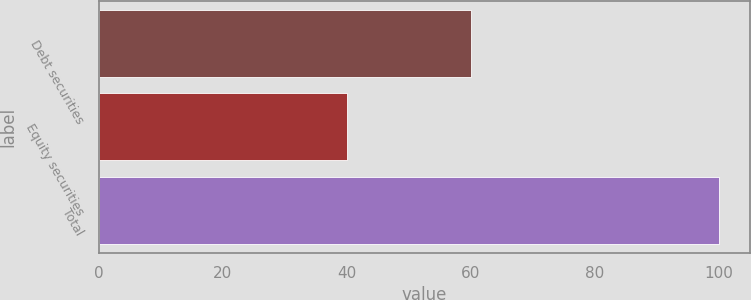Convert chart. <chart><loc_0><loc_0><loc_500><loc_500><bar_chart><fcel>Debt securities<fcel>Equity securities<fcel>Total<nl><fcel>60<fcel>40<fcel>100<nl></chart> 